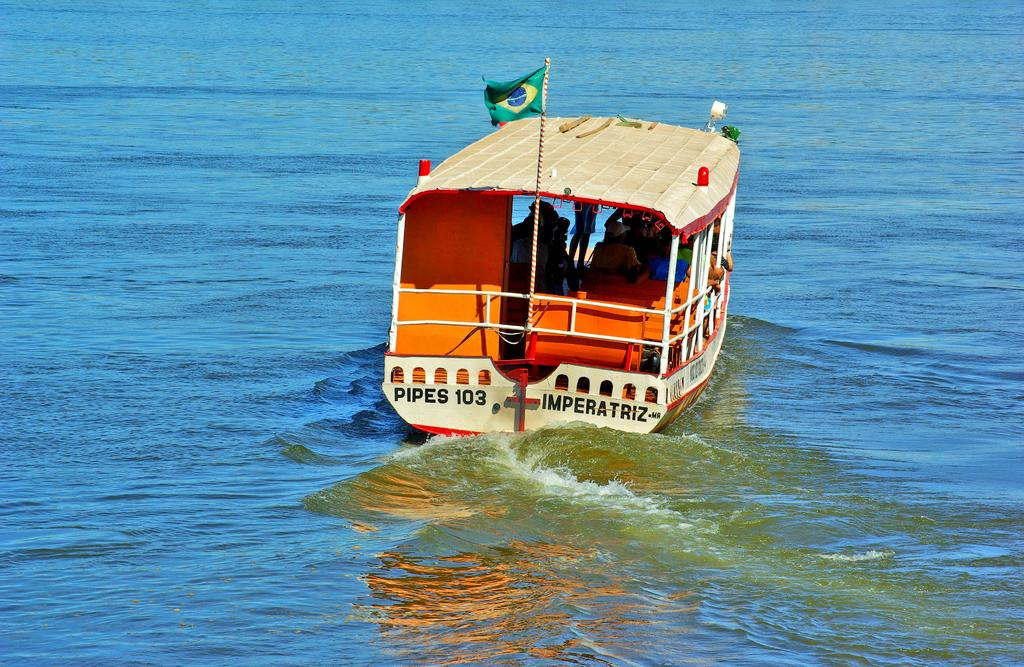What is the main subject of the image? The main subject of the image is a boat. What is the boat doing in the image? The boat is sailing on the water. Are there any people on the boat? Yes, there are persons inside the boat. What is attached to the boat? There is a flag on the boat. What can be seen on the flag? There is text written on the flag. What type of crayon is being used to color the boat in the image? There is no crayon present in the image; it is a photograph or illustration of a real boat. How does the eggnog affect the boat's movement in the image? There is no eggnog present in the image, and therefore it cannot affect the boat's movement. 